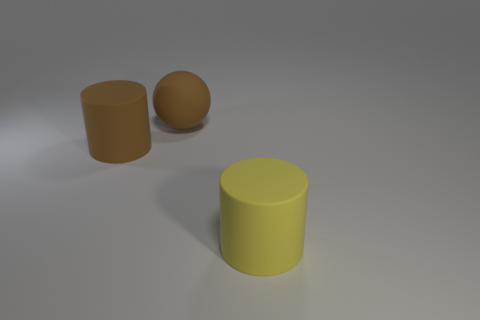Subtract all yellow cylinders. How many cylinders are left? 1 Subtract all balls. How many objects are left? 2 Add 3 big rubber balls. How many objects exist? 6 Subtract 0 cyan cylinders. How many objects are left? 3 Subtract 1 balls. How many balls are left? 0 Subtract all blue cylinders. Subtract all blue blocks. How many cylinders are left? 2 Subtract all big brown matte spheres. Subtract all big balls. How many objects are left? 1 Add 2 large brown objects. How many large brown objects are left? 4 Add 3 tiny gray spheres. How many tiny gray spheres exist? 3 